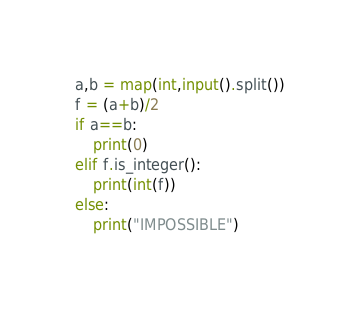<code> <loc_0><loc_0><loc_500><loc_500><_Python_>a,b = map(int,input().split())
f = (a+b)/2
if a==b:
	print(0)
elif f.is_integer():
	print(int(f))
else:
	print("IMPOSSIBLE")</code> 